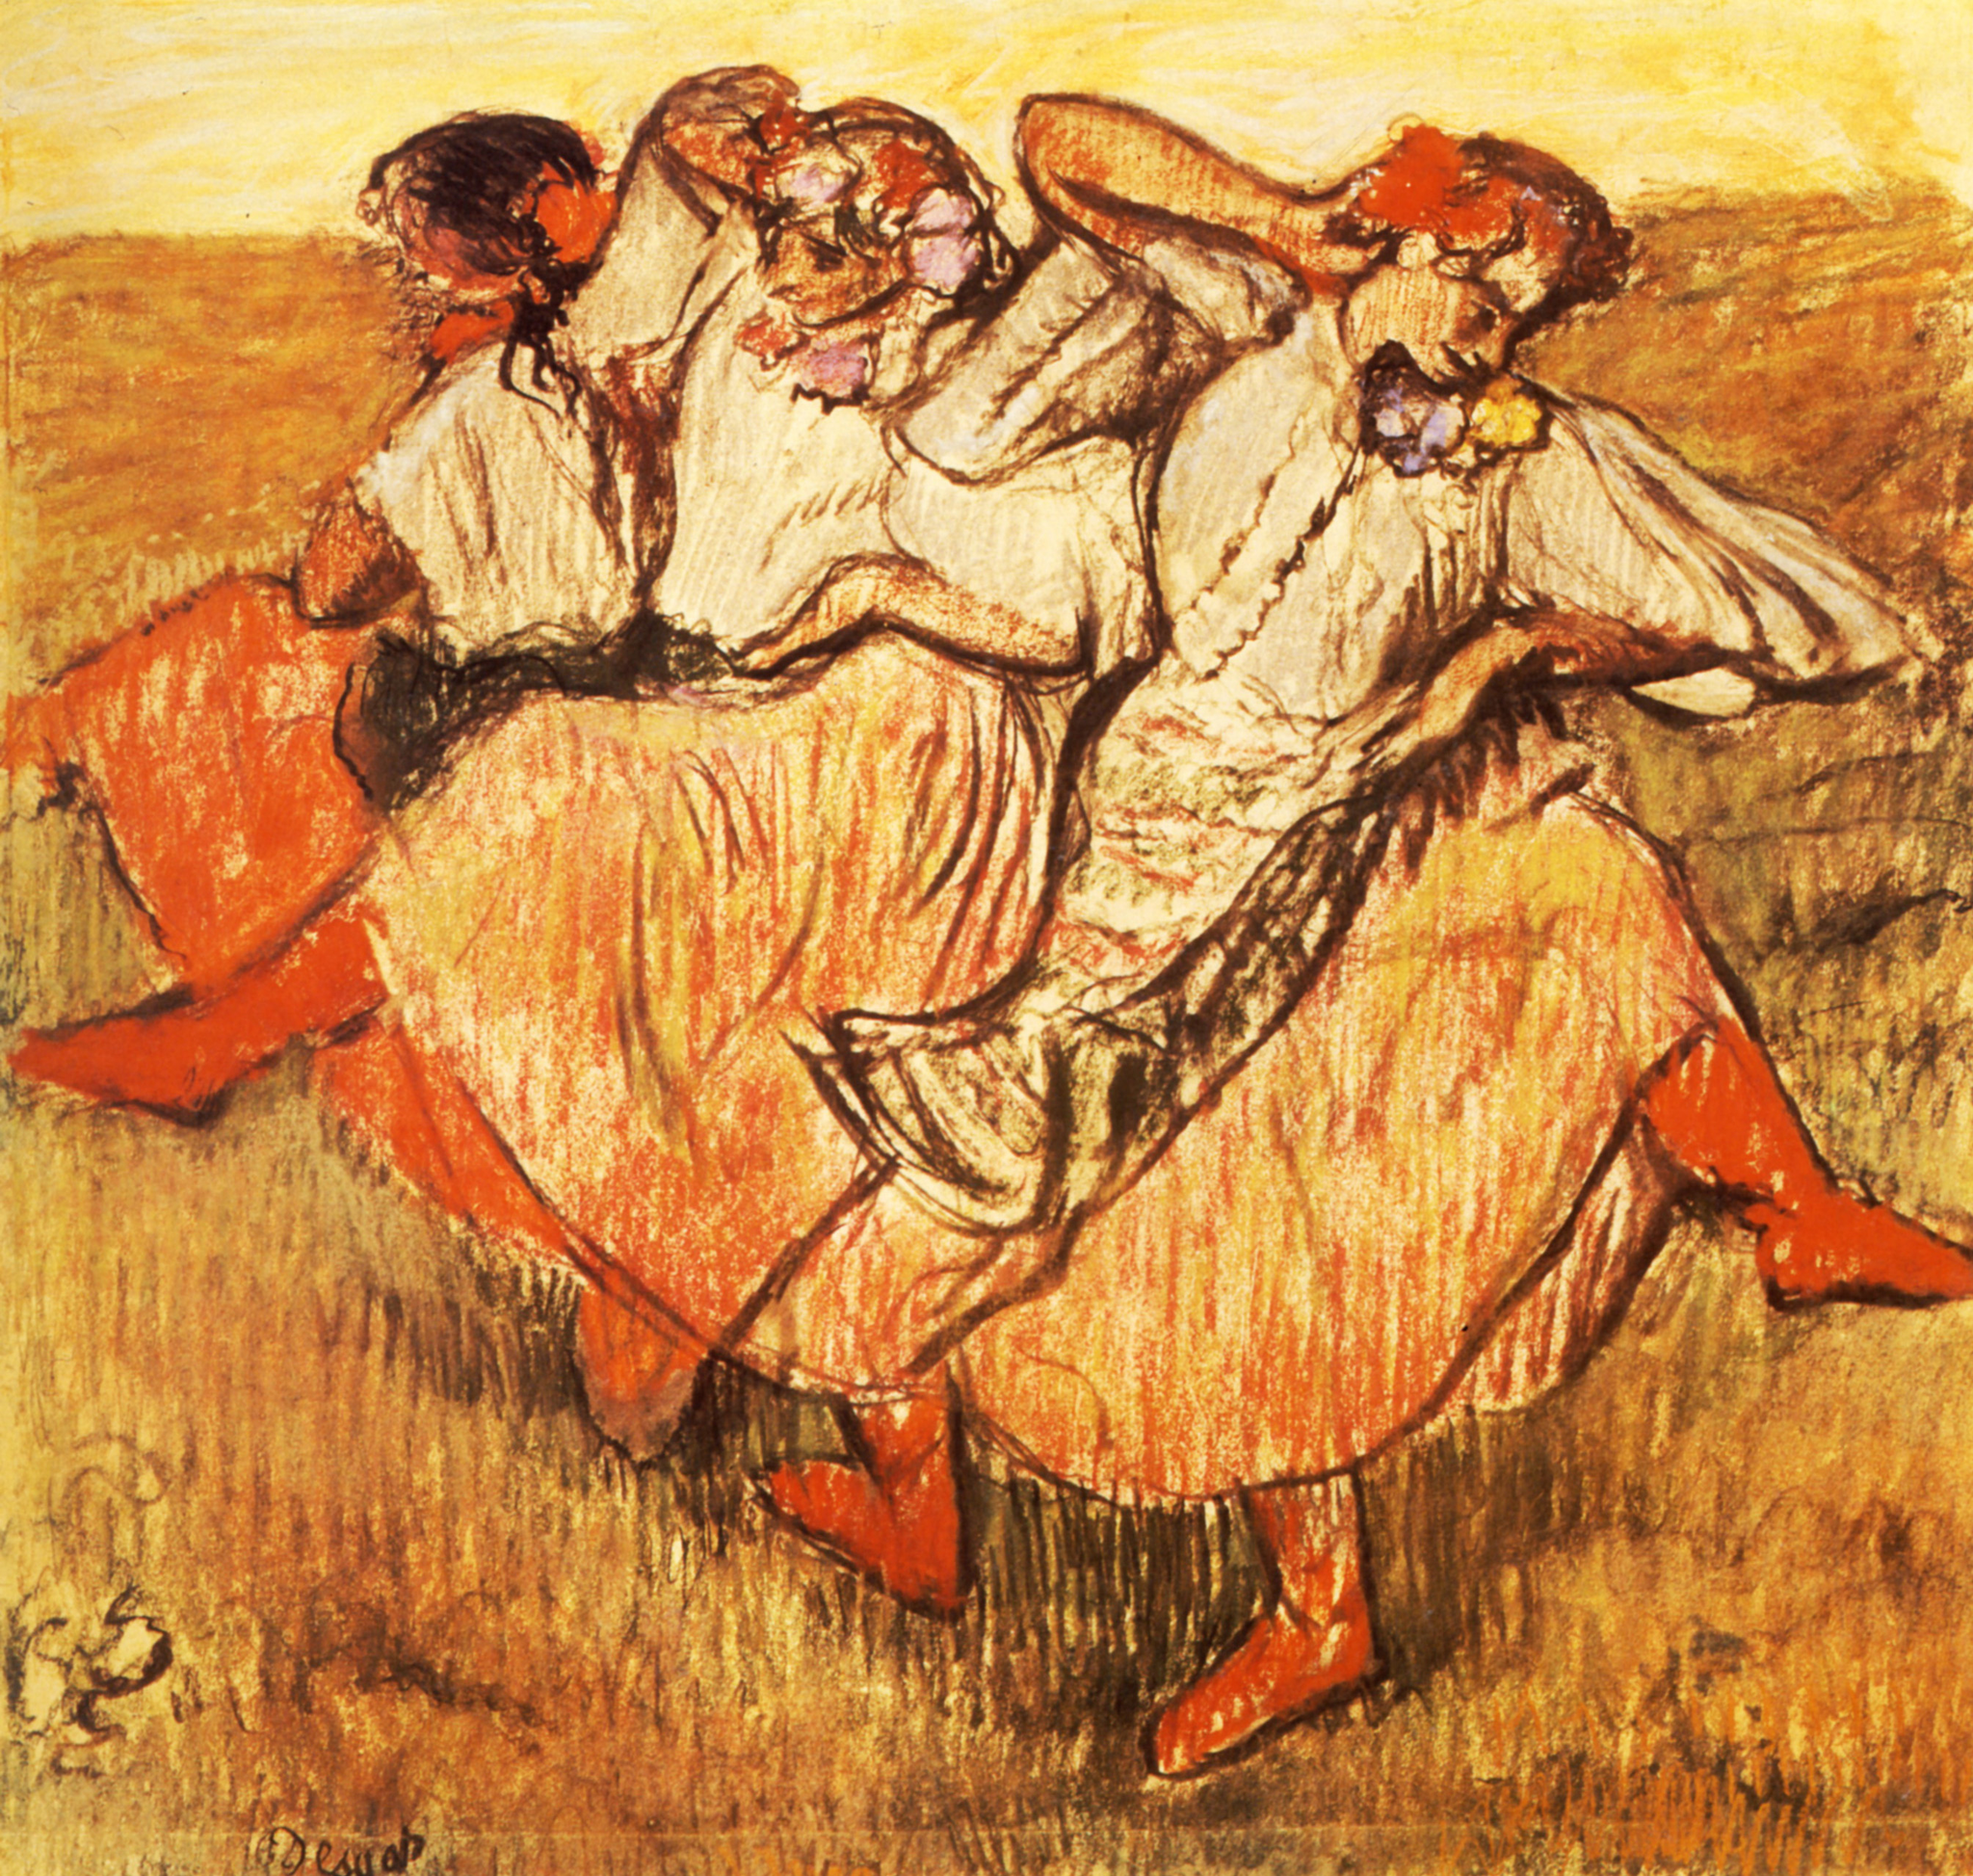What is the mood of the painting, and how is it conveyed through color? The mood of the painting is jubilant and buoyant, which is communicated through the use of warm colors like orange and yellow. These shades evoke the warmth of sunlight and the zest for life. The brushwork is brisk and spontaneous, enhancing the feeling of energy and movement, inviting viewers to share in the dancers' exuberance. 